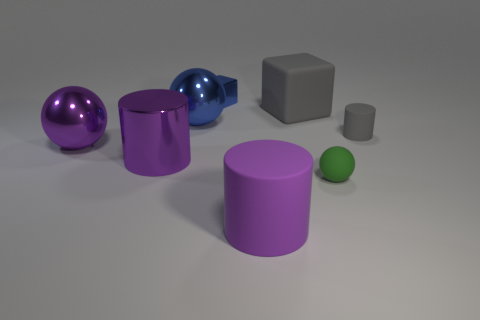Add 1 small green shiny cylinders. How many objects exist? 9 Subtract all large spheres. How many spheres are left? 1 Subtract all gray cubes. How many cubes are left? 1 Subtract all cubes. How many objects are left? 6 Subtract 1 cubes. How many cubes are left? 1 Add 5 yellow metallic balls. How many yellow metallic balls exist? 5 Subtract 0 brown blocks. How many objects are left? 8 Subtract all red cubes. Subtract all purple cylinders. How many cubes are left? 2 Subtract all brown cubes. How many gray cylinders are left? 1 Subtract all small gray metal cylinders. Subtract all big purple metal objects. How many objects are left? 6 